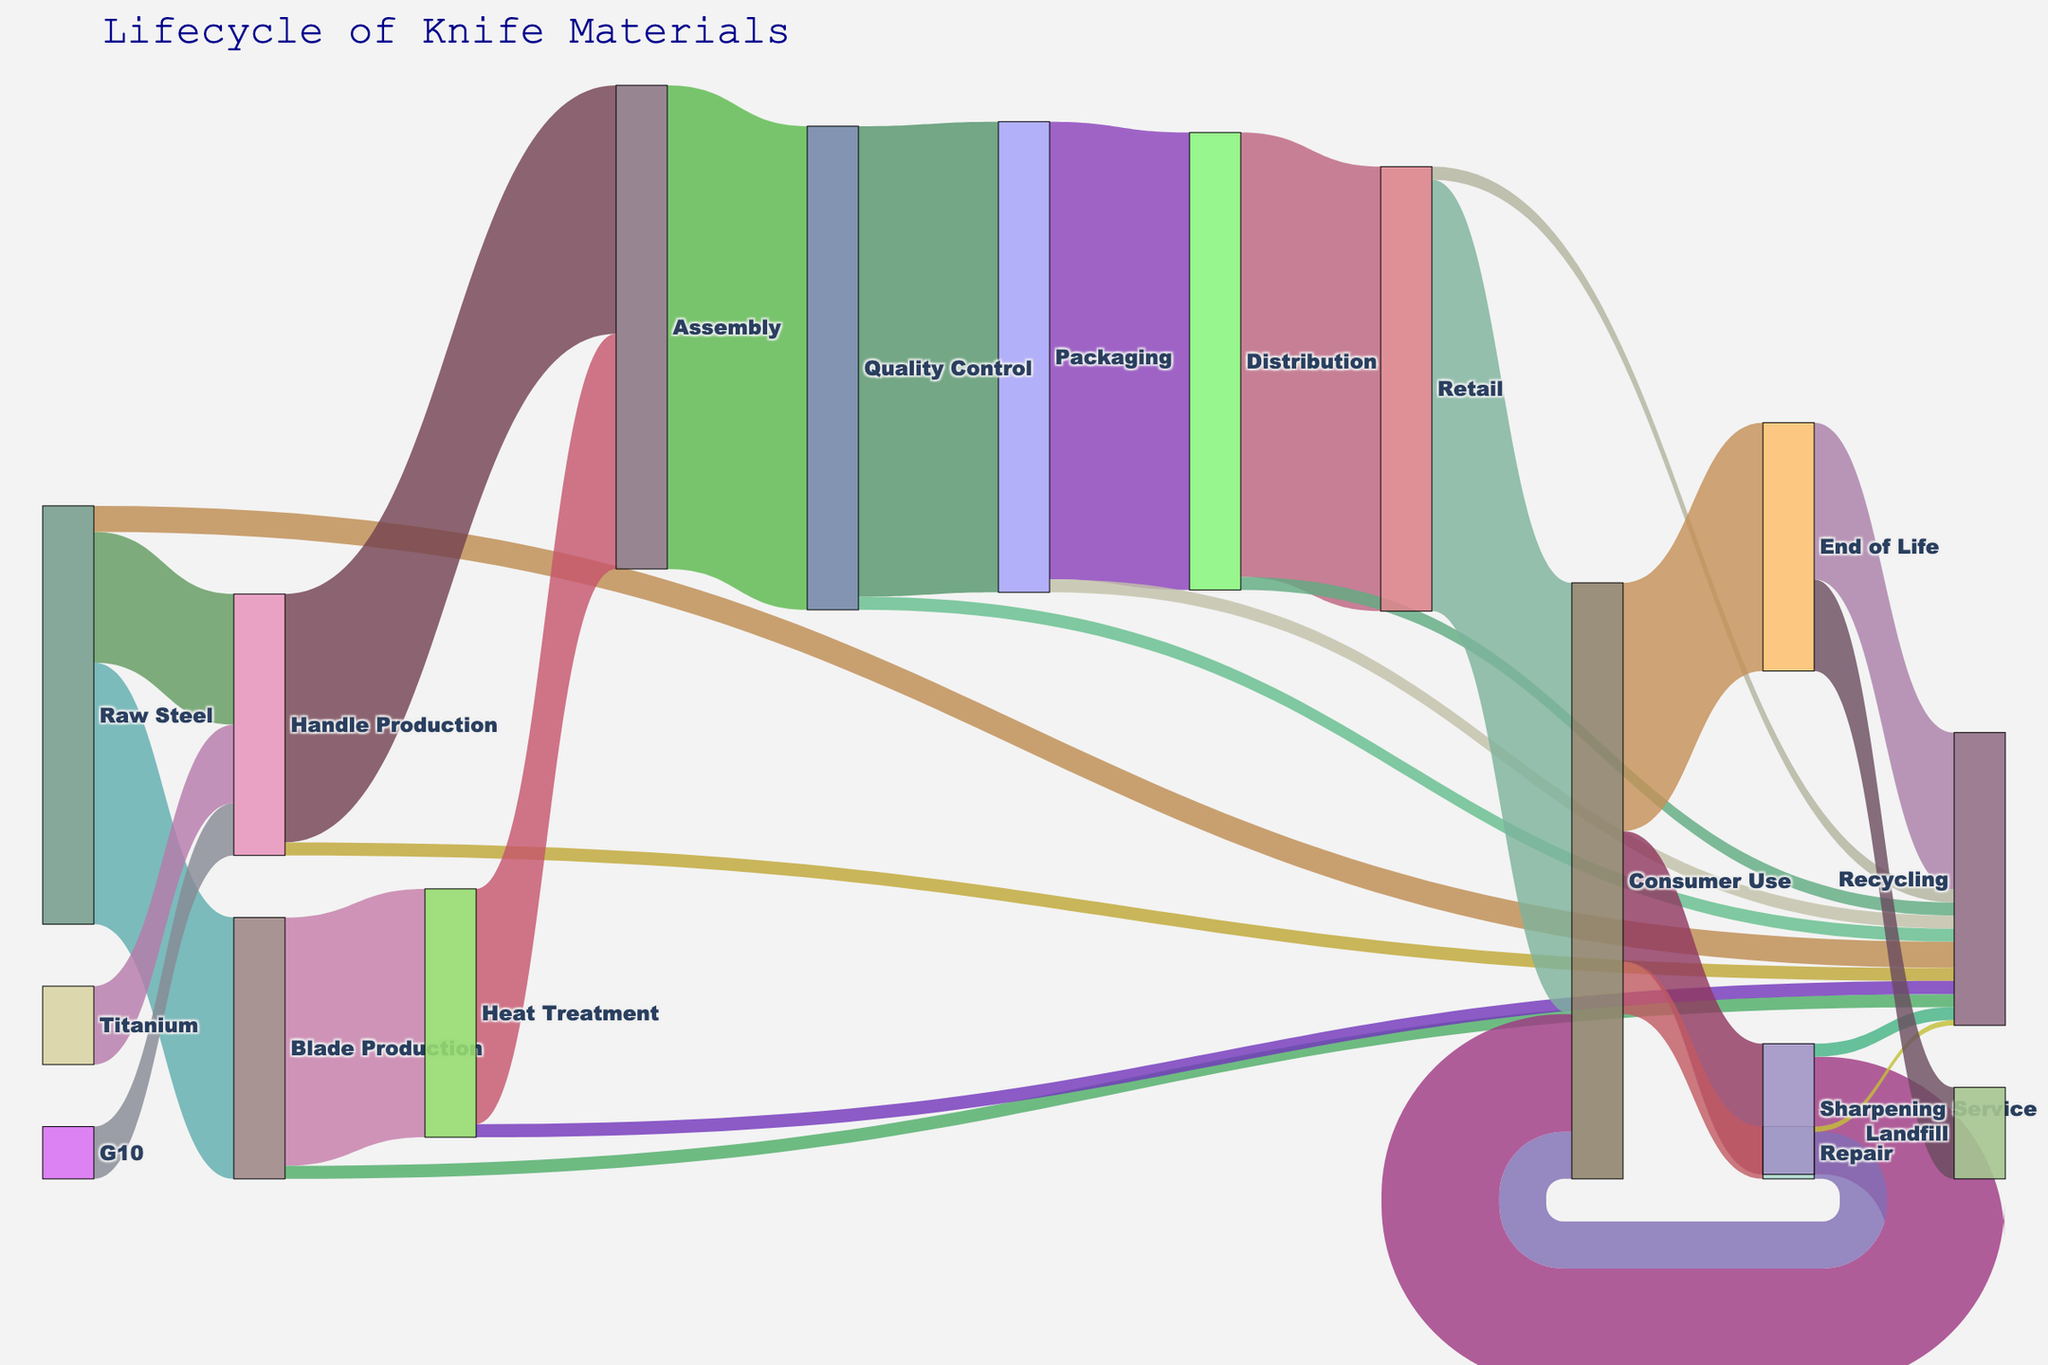What is the title of the Sankey diagram? The title of any chart is usually placed at the top and provides a brief description of the chart's content. The title in this case reads "Lifecycle of Knife Materials".
Answer: Lifecycle of Knife Materials What material is most frequently utilized in blade production? By tracing the source to the "Blade Production" target, we can see that "Raw Steel" has a value of 1000, making it the most frequently utilized material for this purpose.
Answer: Raw Steel How many materials flow into the "Assembly" stage? The "Assembly" stage receives flows from both "Handle Production" (950) and "Heat Treatment" (900). Adding these values, the total number of materials flowing into "Assembly" is 950 + 900 = 1850.
Answer: 1850 What is the combined value of the flows from "Distribution" to "Retail" and from "Distribution" to "Recycling"? The flows from "Distribution" to "Retail" have a value of 1700 and to "Recycling" have a value of 50. Adding these together, the combined value is 1700 + 50 = 1750.
Answer: 1750 Which stage has the highest number of materials flowing to "Recycling"? By examining all stages that have flows towards "Recycling," "End of Life" has the highest with 600.
Answer: End of Life How does the flow quantity from "Consumer Use" to "Repair" compare to the quantity from "Consumer Use" to "Sharpening Service"? "Consumer Use" to "Repair" has a value of 200, while "Consumer Use" to "Sharpening Service" has a value of 500. Therefore, the flow to "Sharpening Service" is greater.
Answer: Sharpening Service How many stages involve the use of "Titanium" as a material? Tracking the flow from "Titanium", it is only utilized in the "Handle Production" stage, giving us a total of one stage.
Answer: 1 What is the total amount of materials that end up in landfills? The "End of Life" stage has a flow towards "Landfill" with a value of 350. This is the only flow to landfills.
Answer: 350 Which production stage handles the highest initial quantity of raw materials? Evaluating the incoming flows to initial production stages, "Blade Production" handles 1000 from "Raw Steel", which is the highest.
Answer: Blade Production How many materials get recycled after "Heat Treatment"? The flow from "Heat Treatment" to "Recycling" has a value of 50.
Answer: 50 